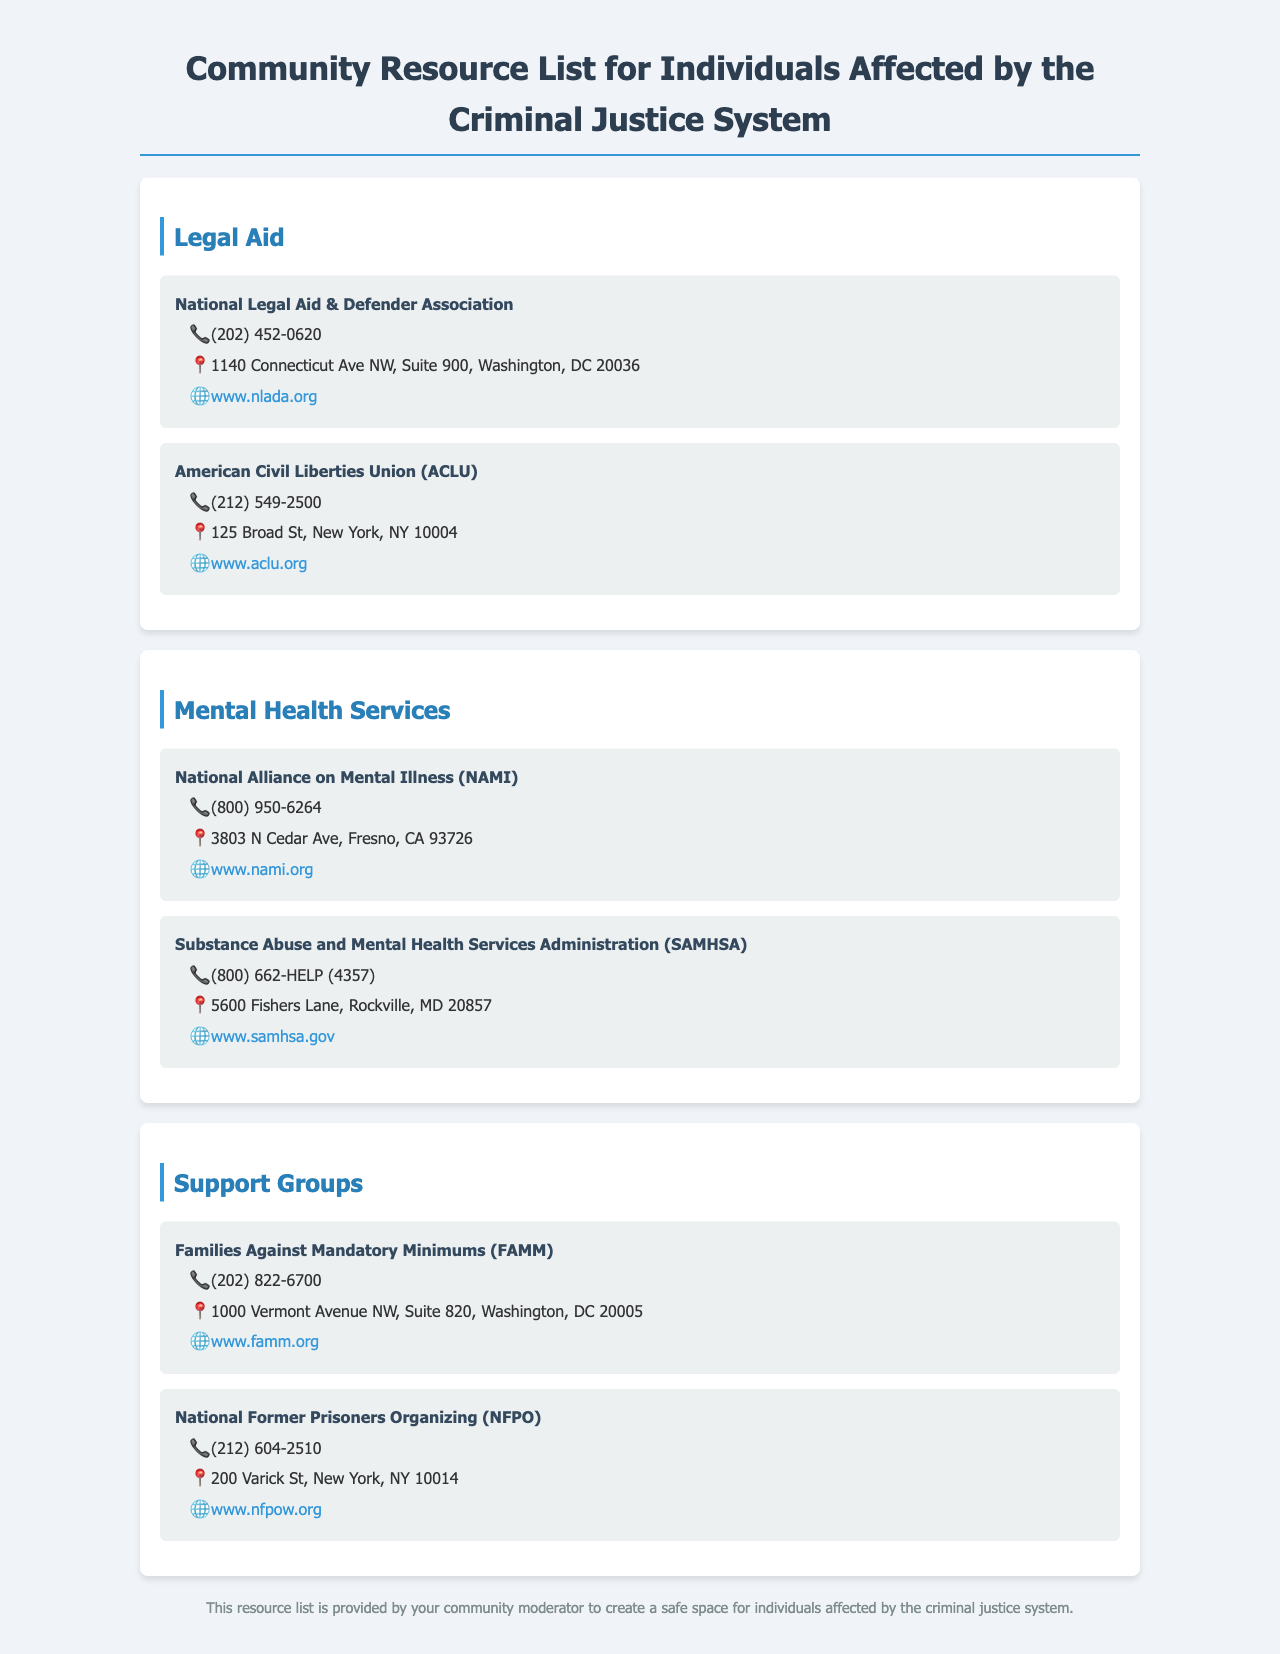What is the phone number for National Legal Aid & Defender Association? The phone number can be found in the contact information section for this legal aid resource.
Answer: (202) 452-0620 What is the address of the American Civil Liberties Union (ACLU)? The address is provided in the contact information section for this organization listed under legal aid.
Answer: 125 Broad St, New York, NY 10004 What services does NAMI provide? NAMI is categorized under mental health services in the document, indicating they offer support related to mental health.
Answer: Mental health services Which organization is located at 3803 N Cedar Ave? The organization associated with that address can be found in the mental health services section.
Answer: National Alliance on Mental Illness (NAMI) What is the website of Families Against Mandatory Minimums? The website can be found in the detailed contact information for this support group in the document.
Answer: www.famm.org How many organizations are listed under Support Groups? The document provides specific sections for each category, and the number of organizations can be counted in the Support Groups section.
Answer: 2 What is the email or website for Substance Abuse and Mental Health Services Administration? The contact information section includes the web address for this organization under mental health services.
Answer: www.samhsa.gov Why is this resource list provided? The footer of the document explains the purpose of this list related to creating a safe space for specific individuals.
Answer: To create a safe space for individuals affected by the criminal justice system 